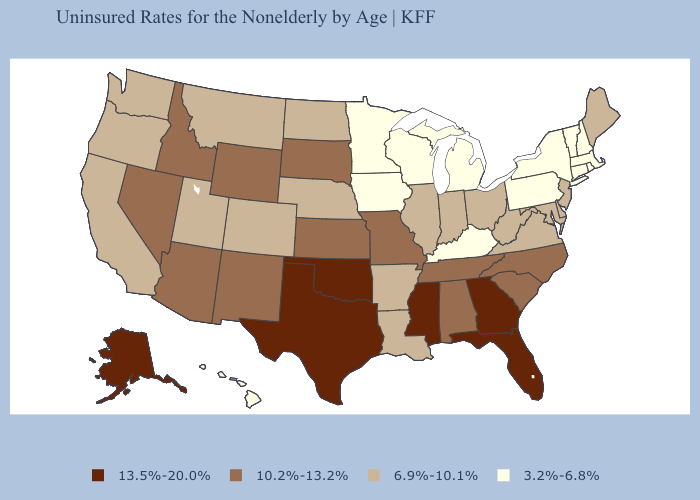What is the lowest value in the USA?
Write a very short answer. 3.2%-6.8%. Does Montana have a lower value than Arkansas?
Write a very short answer. No. Name the states that have a value in the range 3.2%-6.8%?
Write a very short answer. Connecticut, Hawaii, Iowa, Kentucky, Massachusetts, Michigan, Minnesota, New Hampshire, New York, Pennsylvania, Rhode Island, Vermont, Wisconsin. Name the states that have a value in the range 13.5%-20.0%?
Be succinct. Alaska, Florida, Georgia, Mississippi, Oklahoma, Texas. What is the highest value in the MidWest ?
Keep it brief. 10.2%-13.2%. Name the states that have a value in the range 3.2%-6.8%?
Quick response, please. Connecticut, Hawaii, Iowa, Kentucky, Massachusetts, Michigan, Minnesota, New Hampshire, New York, Pennsylvania, Rhode Island, Vermont, Wisconsin. Name the states that have a value in the range 13.5%-20.0%?
Quick response, please. Alaska, Florida, Georgia, Mississippi, Oklahoma, Texas. What is the lowest value in the South?
Quick response, please. 3.2%-6.8%. Is the legend a continuous bar?
Concise answer only. No. Does Arkansas have a higher value than Michigan?
Give a very brief answer. Yes. What is the value of Pennsylvania?
Short answer required. 3.2%-6.8%. How many symbols are there in the legend?
Write a very short answer. 4. Name the states that have a value in the range 10.2%-13.2%?
Quick response, please. Alabama, Arizona, Idaho, Kansas, Missouri, Nevada, New Mexico, North Carolina, South Carolina, South Dakota, Tennessee, Wyoming. Which states have the lowest value in the West?
Concise answer only. Hawaii. What is the lowest value in the USA?
Short answer required. 3.2%-6.8%. 